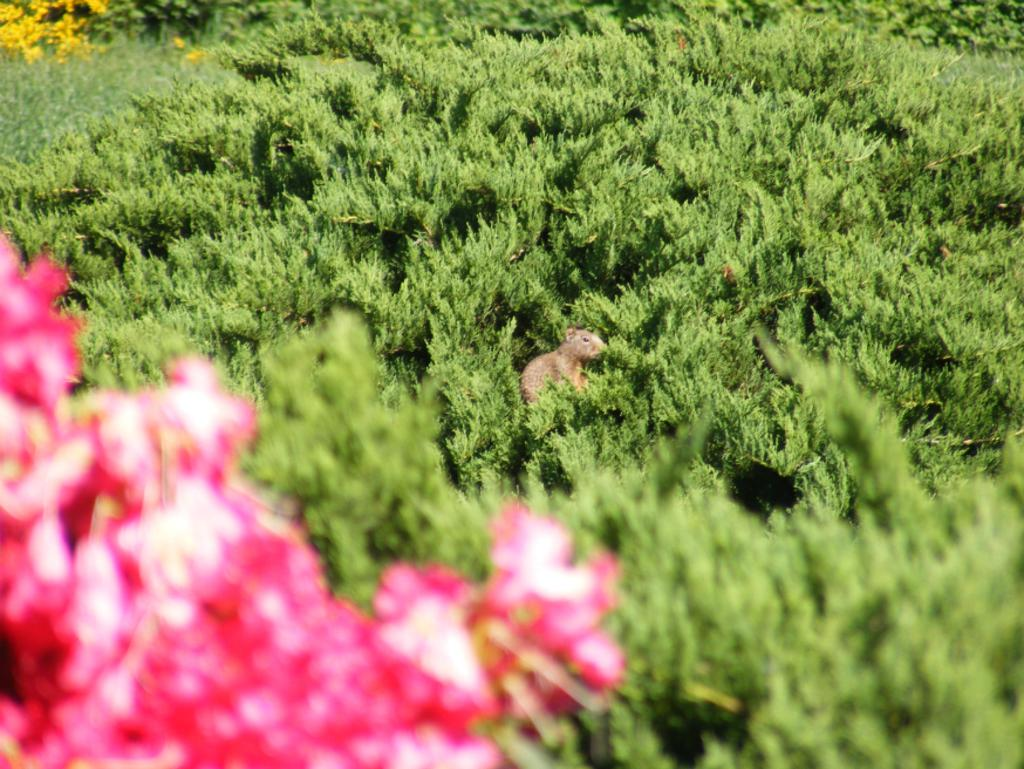What is the main subject of the image? There is a squirrel in the center of the image. What can be seen in the background or surrounding the squirrel? There is greenery around the area of the image. How many passengers are in the cabbage in the image? There is no cabbage or passengers present in the image; it features a squirrel and greenery. 